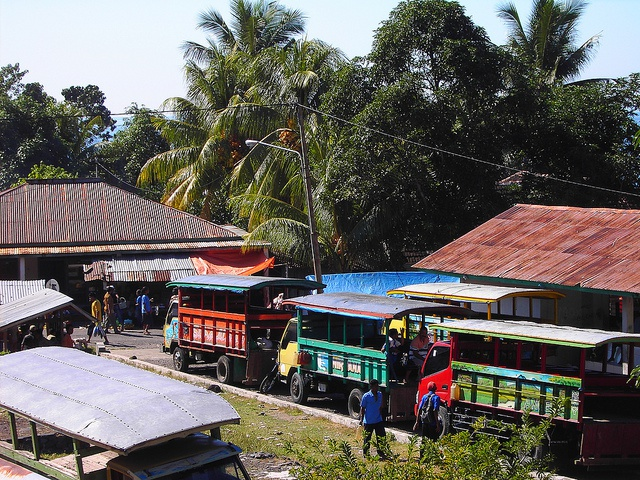Describe the objects in this image and their specific colors. I can see bus in white, black, lightgray, gray, and darkgray tones, bus in white, black, darkgray, gray, and lavender tones, truck in white, black, maroon, lavender, and gray tones, bus in white, black, lightgray, gray, and maroon tones, and people in white, black, gray, navy, and darkgray tones in this image. 